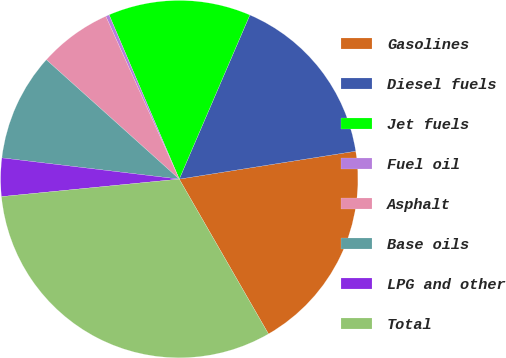Convert chart to OTSL. <chart><loc_0><loc_0><loc_500><loc_500><pie_chart><fcel>Gasolines<fcel>Diesel fuels<fcel>Jet fuels<fcel>Fuel oil<fcel>Asphalt<fcel>Base oils<fcel>LPG and other<fcel>Total<nl><fcel>19.18%<fcel>16.04%<fcel>12.89%<fcel>0.32%<fcel>6.61%<fcel>9.75%<fcel>3.46%<fcel>31.76%<nl></chart> 